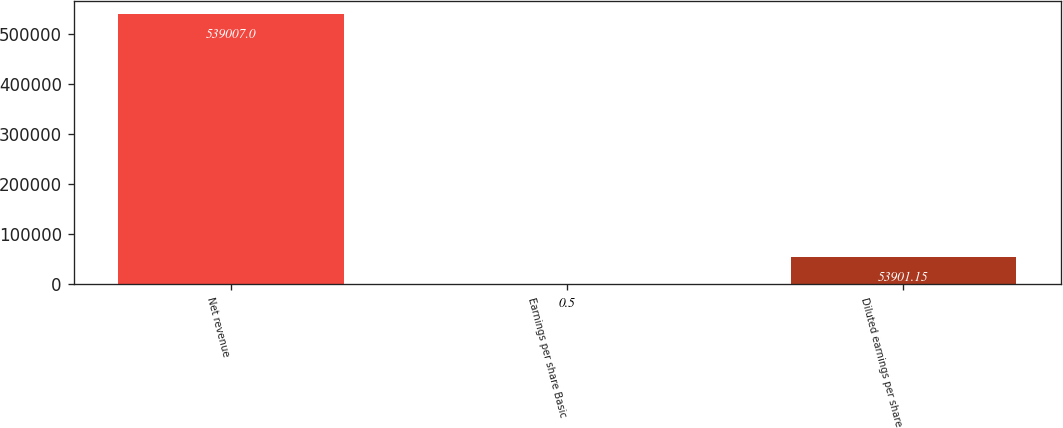Convert chart to OTSL. <chart><loc_0><loc_0><loc_500><loc_500><bar_chart><fcel>Net revenue<fcel>Earnings per share Basic<fcel>Diluted earnings per share<nl><fcel>539007<fcel>0.5<fcel>53901.2<nl></chart> 